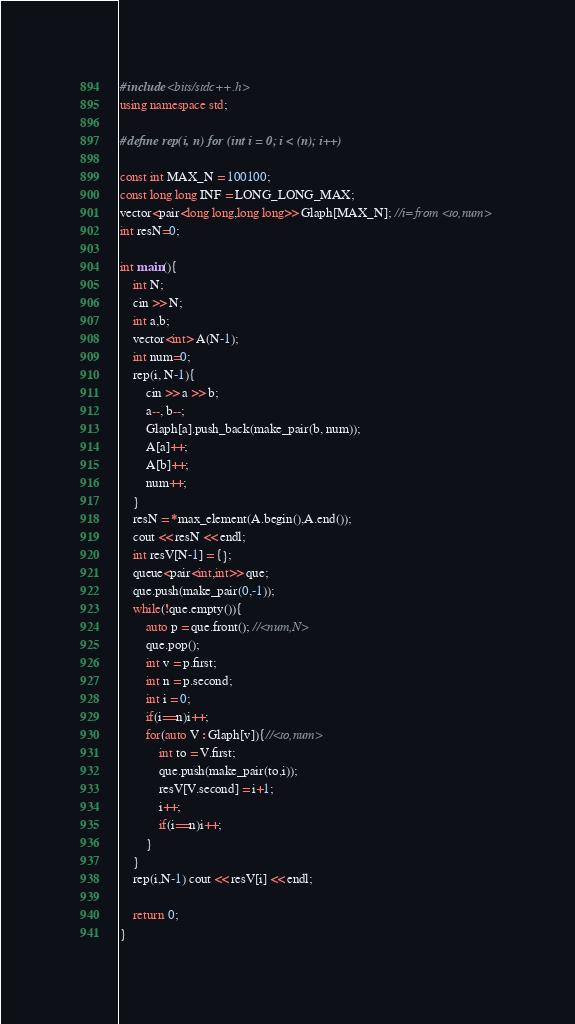<code> <loc_0><loc_0><loc_500><loc_500><_C++_>#include <bits/stdc++.h>
using namespace std;

#define rep(i, n) for (int i = 0; i < (n); i++)

const int MAX_N = 100100;
const long long INF = LONG_LONG_MAX;
vector<pair<long long,long long>> Glaph[MAX_N]; //i=from <to,num> 
int resN=0;
 
int main(){
    int N;
    cin >> N;
    int a,b;
    vector<int> A(N-1);
    int num=0;
    rep(i, N-1){
        cin >> a >> b;
        a--, b--;
        Glaph[a].push_back(make_pair(b, num));
        A[a]++;
        A[b]++;
        num++;
    }
    resN = *max_element(A.begin(),A.end());
    cout << resN << endl;
    int resV[N-1] = {};
    queue<pair<int,int>> que;
    que.push(make_pair(0,-1));
    while(!que.empty()){
        auto p = que.front(); //<num,N>
        que.pop();
        int v = p.first;
        int n = p.second;
        int i = 0;
        if(i==n)i++;
        for(auto V : Glaph[v]){//<to,num>
            int to = V.first;
            que.push(make_pair(to,i));
            resV[V.second] = i+1;
            i++;
            if(i==n)i++;
        }
    }
    rep(i,N-1) cout << resV[i] << endl;

    return 0;
}</code> 